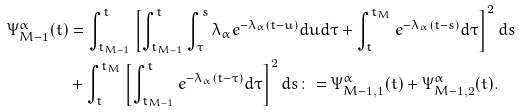Convert formula to latex. <formula><loc_0><loc_0><loc_500><loc_500>\Psi _ { M - 1 } ^ { \alpha } ( t ) & = \int _ { t _ { M - 1 } } ^ { t } \left [ \int _ { t _ { M - 1 } } ^ { t } \int _ { \tau } ^ { s } \lambda _ { \alpha } e ^ { - \lambda _ { \alpha } ( t - u ) } d u d \tau + \int _ { t } ^ { t _ { M } } e ^ { - \lambda _ { \alpha } ( t - s ) } d \tau \right ] ^ { 2 } d s \\ & + \int _ { t } ^ { t _ { M } } \left [ \int _ { t _ { M - 1 } } ^ { t } e ^ { - \lambda _ { \alpha } ( t - \tau ) } d \tau \right ] ^ { 2 } d s \colon = \Psi _ { M - 1 , 1 } ^ { \alpha } ( t ) + \Psi _ { M - 1 , 2 } ^ { \alpha } ( t ) .</formula> 